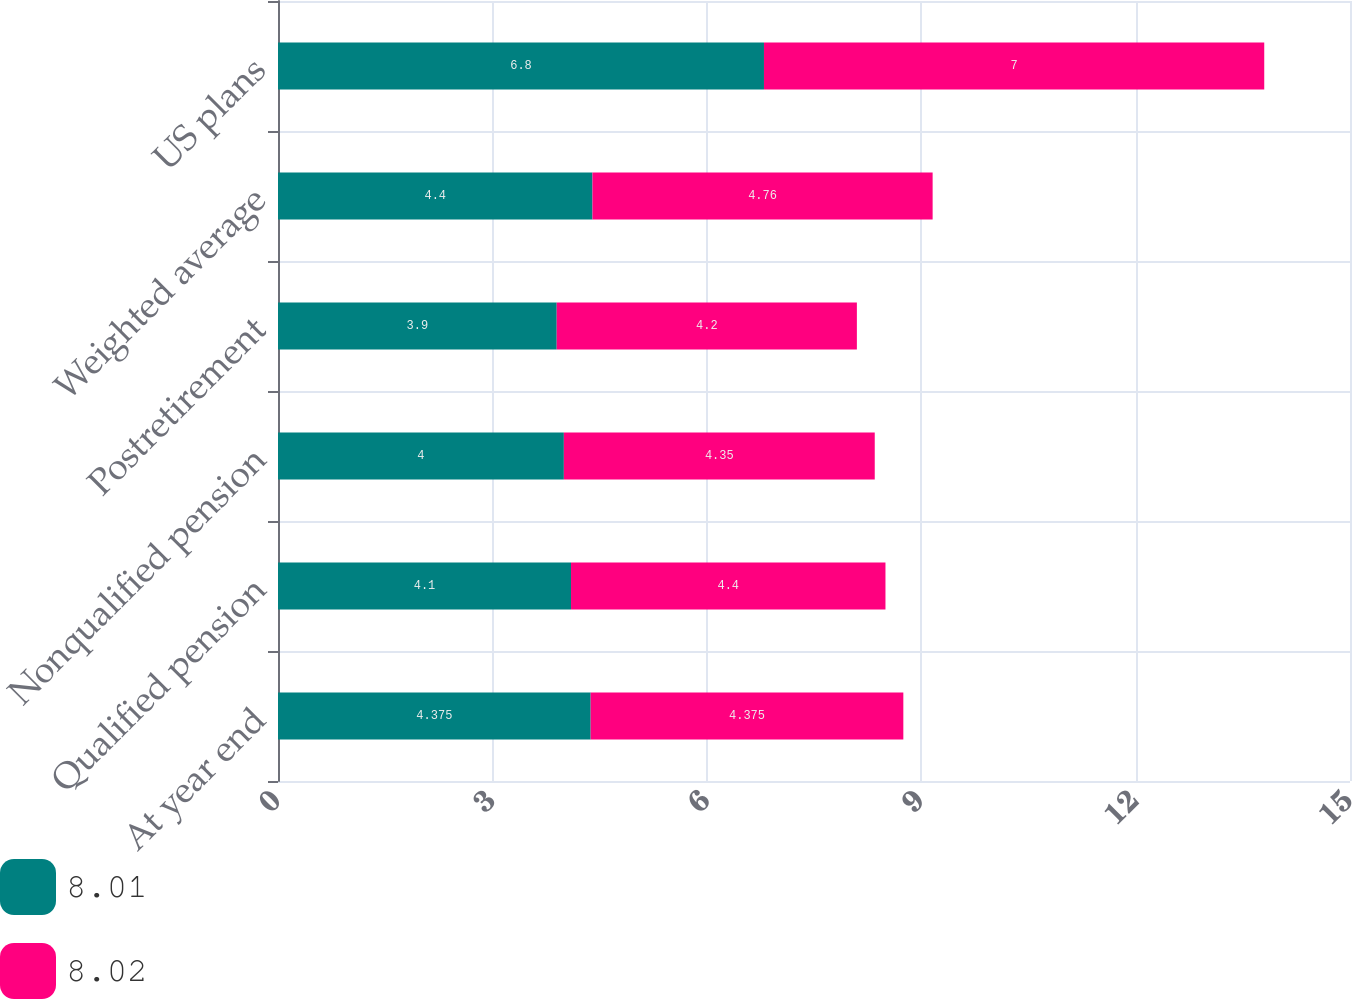Convert chart. <chart><loc_0><loc_0><loc_500><loc_500><stacked_bar_chart><ecel><fcel>At year end<fcel>Qualified pension<fcel>Nonqualified pension<fcel>Postretirement<fcel>Weighted average<fcel>US plans<nl><fcel>8.01<fcel>4.375<fcel>4.1<fcel>4<fcel>3.9<fcel>4.4<fcel>6.8<nl><fcel>8.02<fcel>4.375<fcel>4.4<fcel>4.35<fcel>4.2<fcel>4.76<fcel>7<nl></chart> 